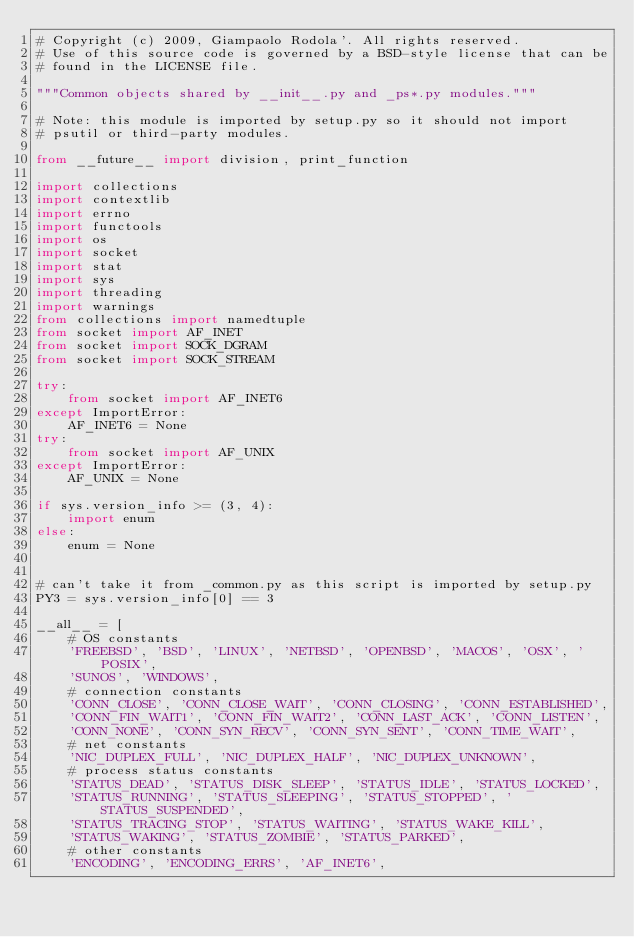<code> <loc_0><loc_0><loc_500><loc_500><_Python_># Copyright (c) 2009, Giampaolo Rodola'. All rights reserved.
# Use of this source code is governed by a BSD-style license that can be
# found in the LICENSE file.

"""Common objects shared by __init__.py and _ps*.py modules."""

# Note: this module is imported by setup.py so it should not import
# psutil or third-party modules.

from __future__ import division, print_function

import collections
import contextlib
import errno
import functools
import os
import socket
import stat
import sys
import threading
import warnings
from collections import namedtuple
from socket import AF_INET
from socket import SOCK_DGRAM
from socket import SOCK_STREAM

try:
    from socket import AF_INET6
except ImportError:
    AF_INET6 = None
try:
    from socket import AF_UNIX
except ImportError:
    AF_UNIX = None

if sys.version_info >= (3, 4):
    import enum
else:
    enum = None


# can't take it from _common.py as this script is imported by setup.py
PY3 = sys.version_info[0] == 3

__all__ = [
    # OS constants
    'FREEBSD', 'BSD', 'LINUX', 'NETBSD', 'OPENBSD', 'MACOS', 'OSX', 'POSIX',
    'SUNOS', 'WINDOWS',
    # connection constants
    'CONN_CLOSE', 'CONN_CLOSE_WAIT', 'CONN_CLOSING', 'CONN_ESTABLISHED',
    'CONN_FIN_WAIT1', 'CONN_FIN_WAIT2', 'CONN_LAST_ACK', 'CONN_LISTEN',
    'CONN_NONE', 'CONN_SYN_RECV', 'CONN_SYN_SENT', 'CONN_TIME_WAIT',
    # net constants
    'NIC_DUPLEX_FULL', 'NIC_DUPLEX_HALF', 'NIC_DUPLEX_UNKNOWN',
    # process status constants
    'STATUS_DEAD', 'STATUS_DISK_SLEEP', 'STATUS_IDLE', 'STATUS_LOCKED',
    'STATUS_RUNNING', 'STATUS_SLEEPING', 'STATUS_STOPPED', 'STATUS_SUSPENDED',
    'STATUS_TRACING_STOP', 'STATUS_WAITING', 'STATUS_WAKE_KILL',
    'STATUS_WAKING', 'STATUS_ZOMBIE', 'STATUS_PARKED',
    # other constants
    'ENCODING', 'ENCODING_ERRS', 'AF_INET6',</code> 